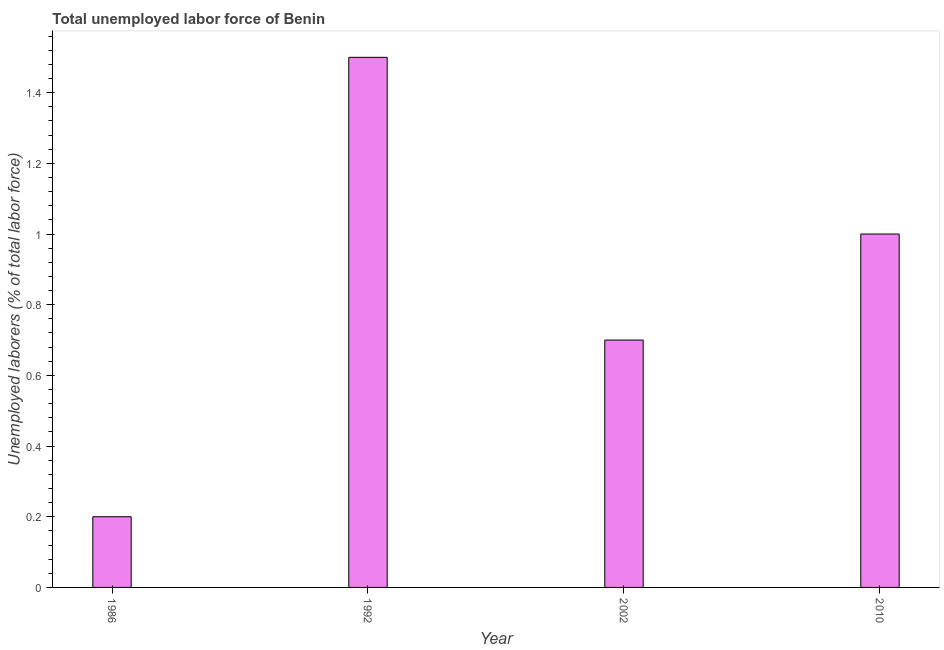What is the title of the graph?
Offer a terse response. Total unemployed labor force of Benin. What is the label or title of the Y-axis?
Your response must be concise. Unemployed laborers (% of total labor force). Across all years, what is the minimum total unemployed labour force?
Ensure brevity in your answer.  0.2. In which year was the total unemployed labour force minimum?
Give a very brief answer. 1986. What is the sum of the total unemployed labour force?
Your response must be concise. 3.4. What is the difference between the total unemployed labour force in 1992 and 2002?
Your response must be concise. 0.8. What is the average total unemployed labour force per year?
Your response must be concise. 0.85. What is the median total unemployed labour force?
Your answer should be compact. 0.85. Do a majority of the years between 1986 and 1992 (inclusive) have total unemployed labour force greater than 0.52 %?
Provide a succinct answer. No. What is the ratio of the total unemployed labour force in 1992 to that in 2010?
Keep it short and to the point. 1.5. Is the difference between the total unemployed labour force in 1992 and 2002 greater than the difference between any two years?
Keep it short and to the point. No. What is the difference between the highest and the second highest total unemployed labour force?
Make the answer very short. 0.5. Is the sum of the total unemployed labour force in 1992 and 2010 greater than the maximum total unemployed labour force across all years?
Your response must be concise. Yes. What is the difference between the highest and the lowest total unemployed labour force?
Make the answer very short. 1.3. How many bars are there?
Ensure brevity in your answer.  4. Are the values on the major ticks of Y-axis written in scientific E-notation?
Offer a terse response. No. What is the Unemployed laborers (% of total labor force) of 1986?
Offer a terse response. 0.2. What is the Unemployed laborers (% of total labor force) in 1992?
Offer a terse response. 1.5. What is the Unemployed laborers (% of total labor force) in 2002?
Provide a short and direct response. 0.7. What is the difference between the Unemployed laborers (% of total labor force) in 1986 and 1992?
Offer a very short reply. -1.3. What is the difference between the Unemployed laborers (% of total labor force) in 1986 and 2010?
Your answer should be very brief. -0.8. What is the difference between the Unemployed laborers (% of total labor force) in 2002 and 2010?
Keep it short and to the point. -0.3. What is the ratio of the Unemployed laborers (% of total labor force) in 1986 to that in 1992?
Your response must be concise. 0.13. What is the ratio of the Unemployed laborers (% of total labor force) in 1986 to that in 2002?
Keep it short and to the point. 0.29. What is the ratio of the Unemployed laborers (% of total labor force) in 1992 to that in 2002?
Ensure brevity in your answer.  2.14. What is the ratio of the Unemployed laborers (% of total labor force) in 1992 to that in 2010?
Offer a very short reply. 1.5. What is the ratio of the Unemployed laborers (% of total labor force) in 2002 to that in 2010?
Offer a terse response. 0.7. 